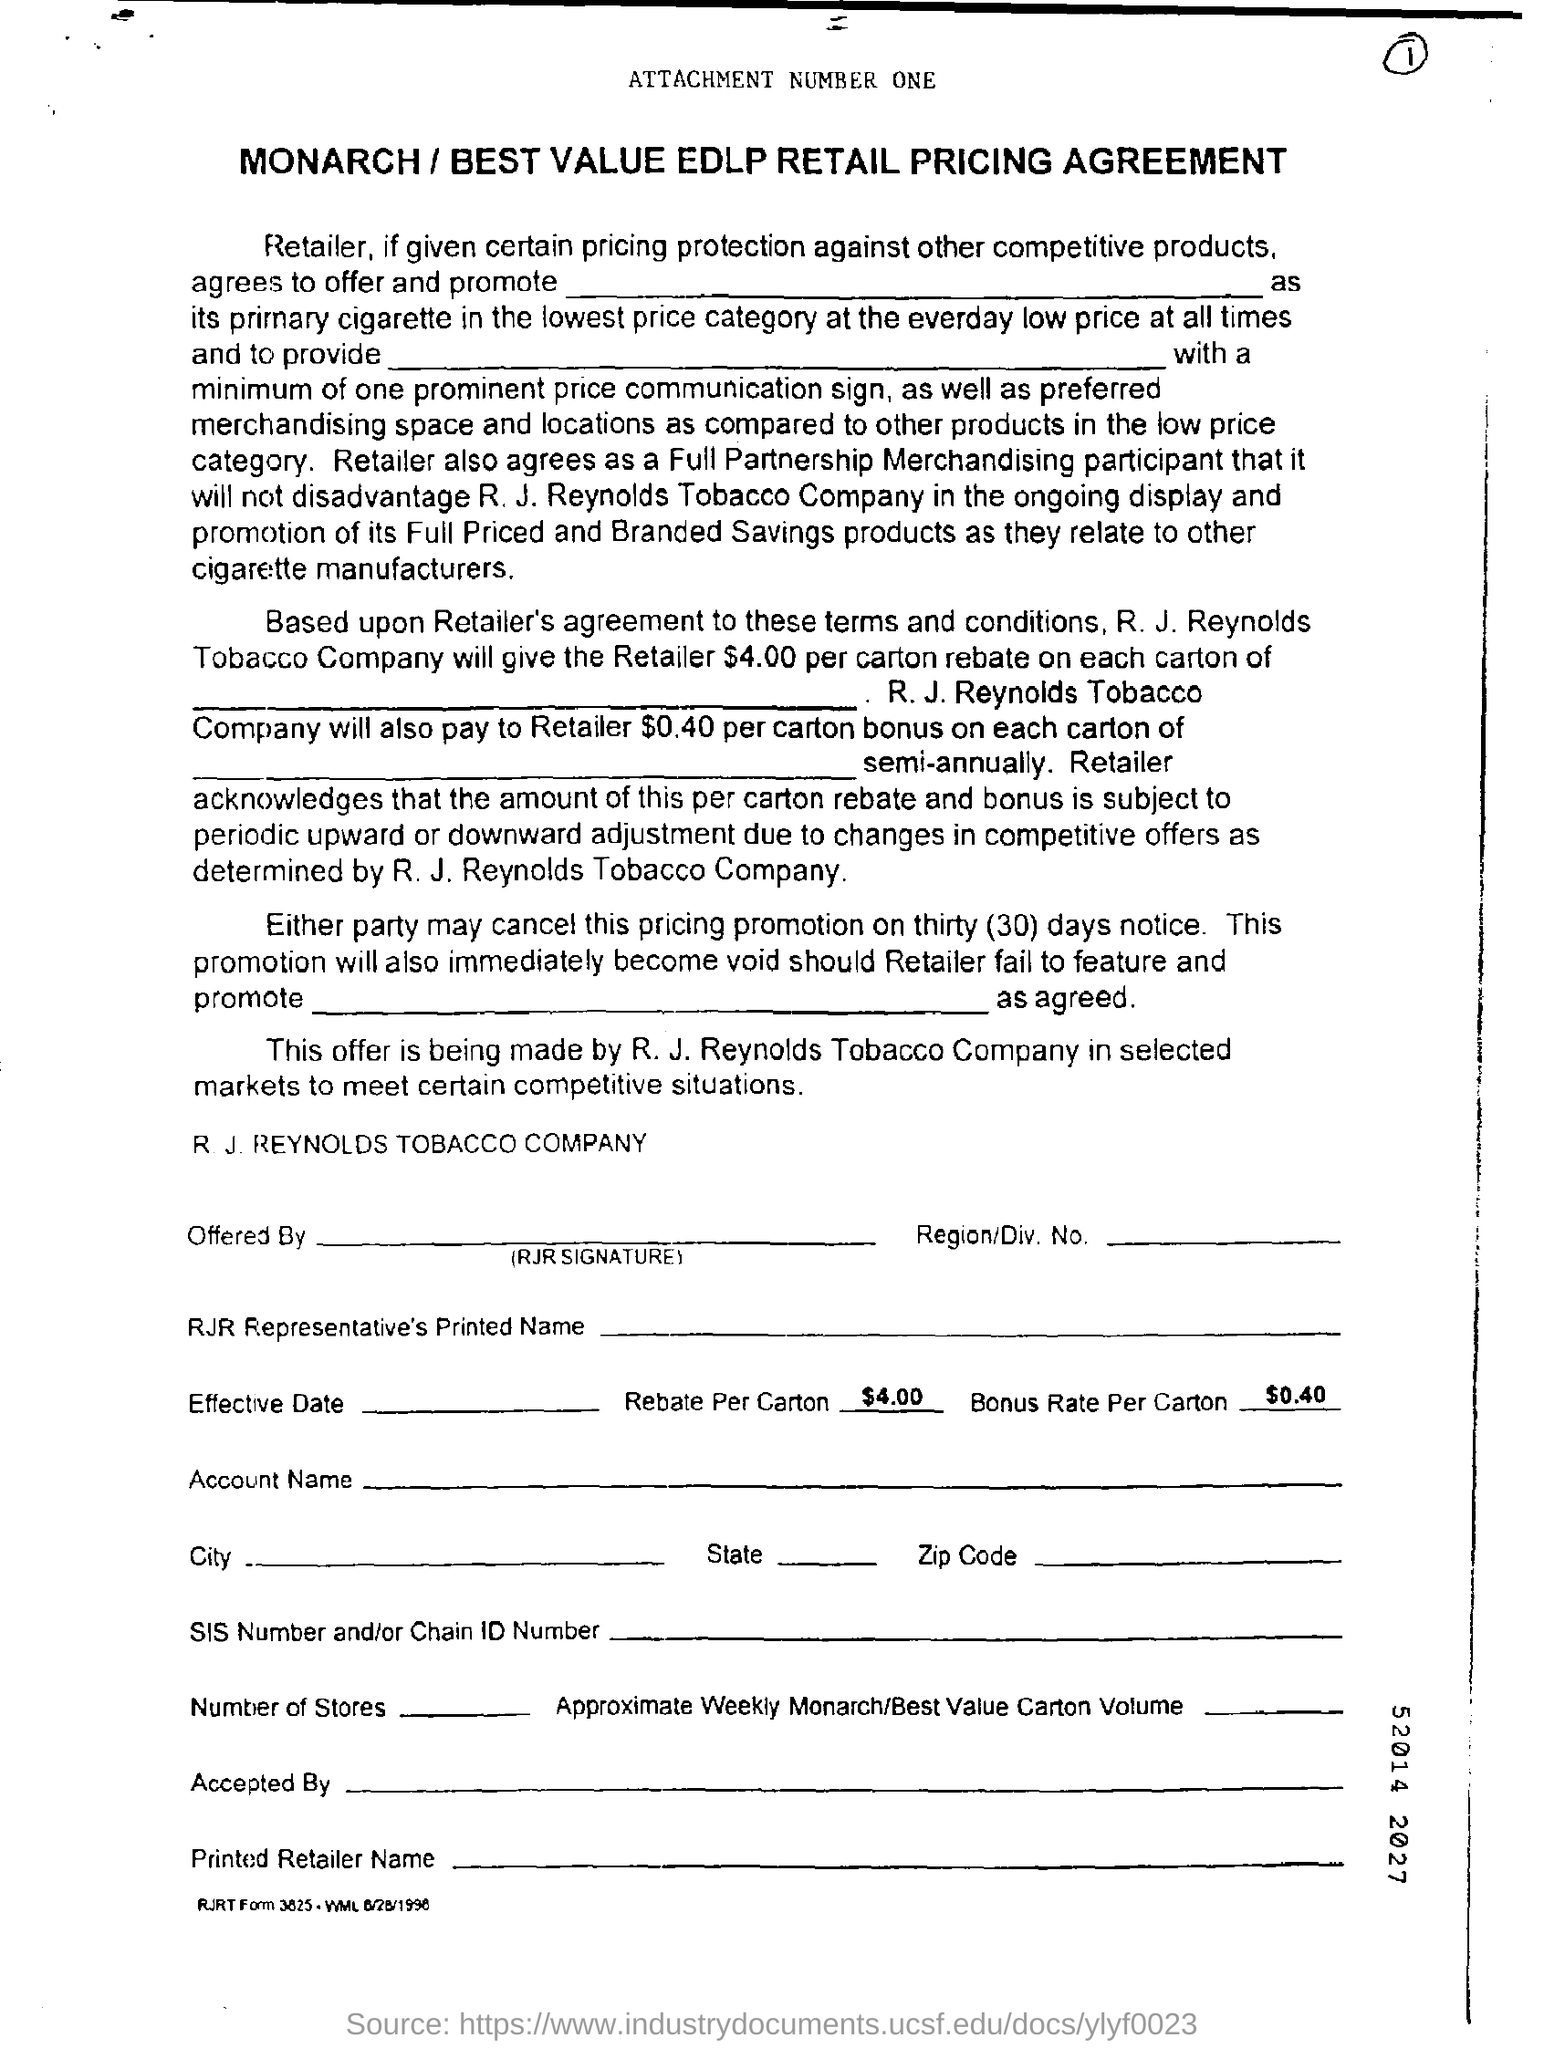Draw attention to some important aspects in this diagram. The rebate per carton is $4.00. The Bonus Rate Per Carton is $0.40 per carton. The notice period for canceling a pricing promotion is thirty days. 